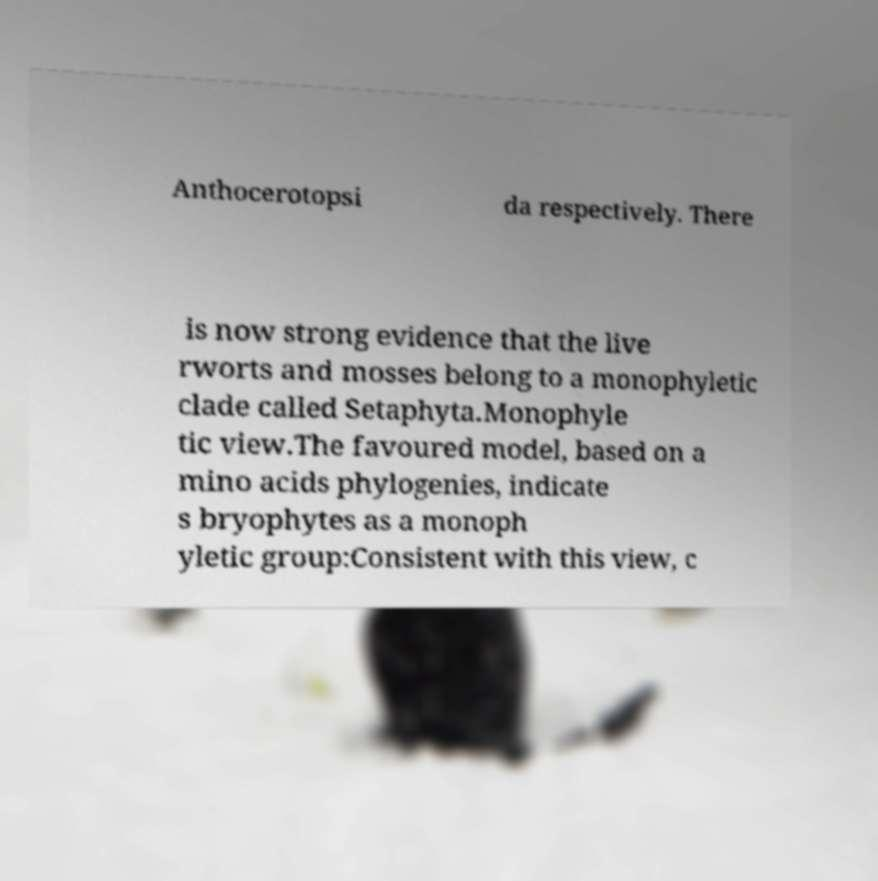I need the written content from this picture converted into text. Can you do that? Anthocerotopsi da respectively. There is now strong evidence that the live rworts and mosses belong to a monophyletic clade called Setaphyta.Monophyle tic view.The favoured model, based on a mino acids phylogenies, indicate s bryophytes as a monoph yletic group:Consistent with this view, c 